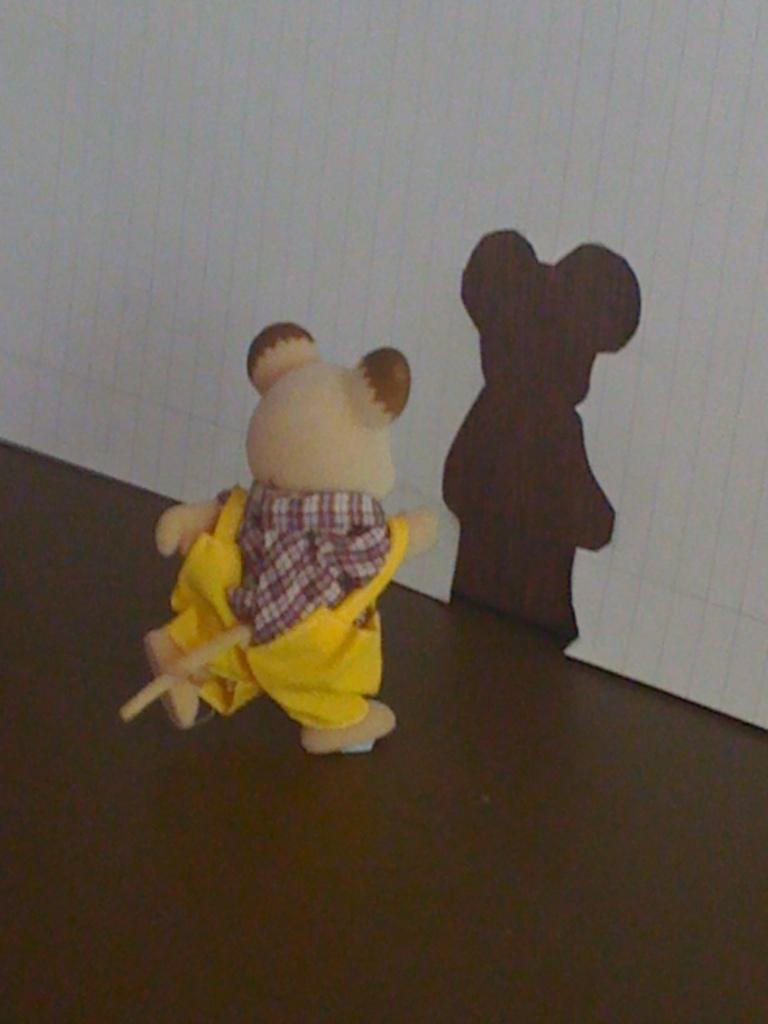Could you give a brief overview of what you see in this image? This picture shows about the small yellow color teddy bear toys placed on the table. Behind you can see a shadow on the white wall. 